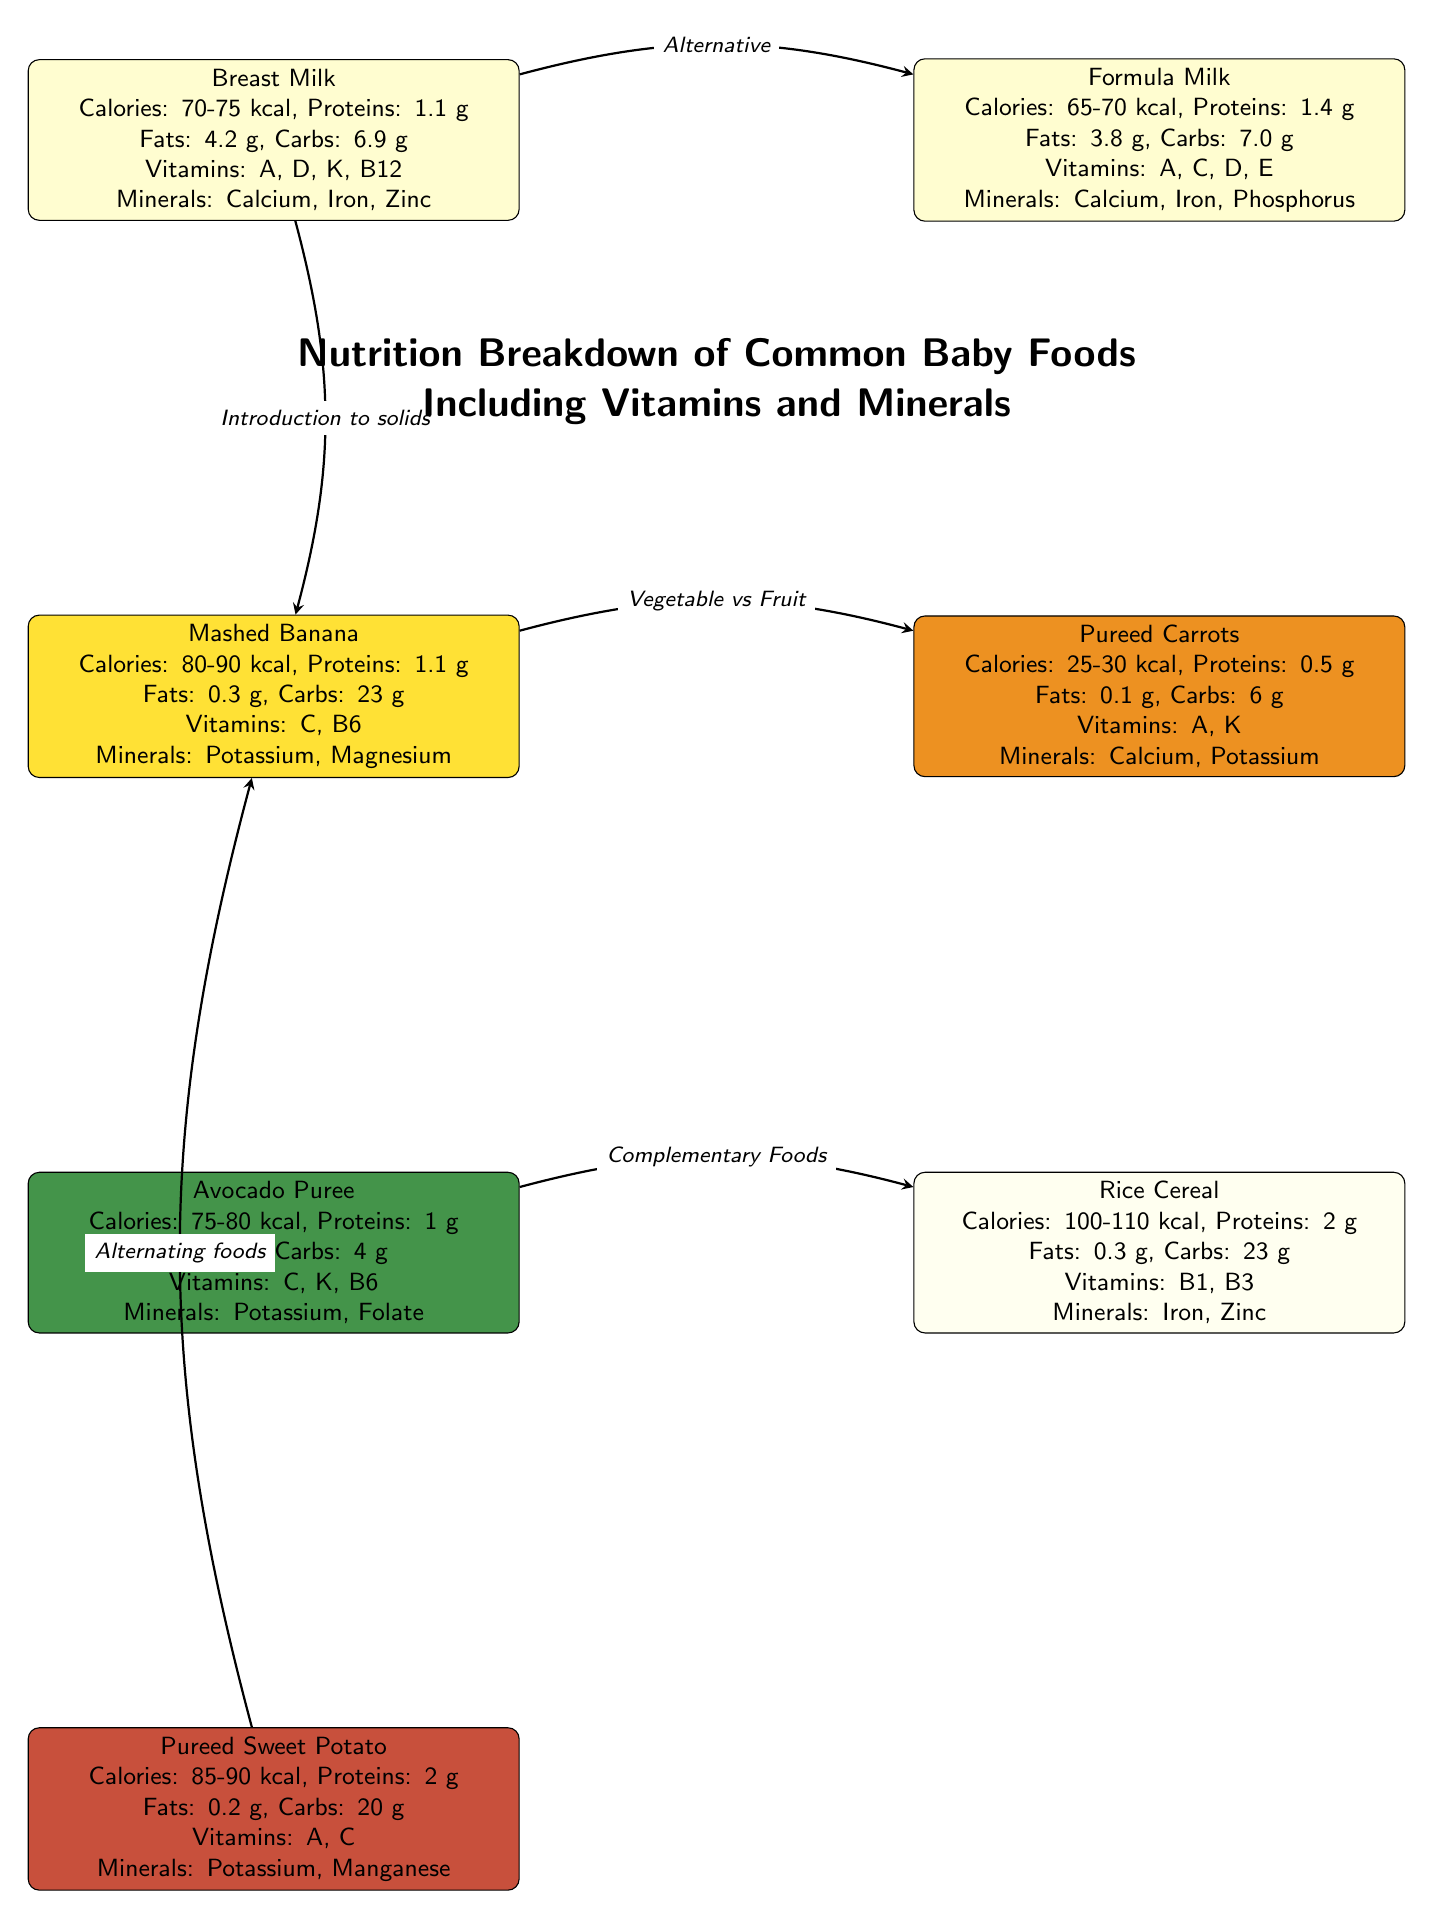What is the calorie range for Breast Milk? The diagram specifies that Breast Milk has a calorie range of 70-75 kcal. By referencing the node labeled "Breast Milk" and looking at the nutritional information listed, we find this value directly mentioned.
Answer: 70-75 kcal Which vitamin is present in both Avocado Puree and Mashed Banana? Both Avocado Puree and Mashed Banana include the vitamin C. By checking the vitamin lists under the respective nodes, we see that "C" appears in both cases.
Answer: C How many food items are listed in the diagram? The diagram includes six distinct food items: Breast Milk, Formula Milk, Mashed Banana, Pureed Carrots, Avocado Puree, Rice Cereal, and Pureed Sweet Potato. By simply counting the nodes in the diagram, we find the total.
Answer: 6 What is the main mineral found in both Pureed Sweet Potato and Mashed Banana? The main mineral found in both Pureed Sweet Potato and Mashed Banana is Potassium. Looking at the mineral sections in both food nodes, we identify Potassium listed under each.
Answer: Potassium What is the main dietary fat content of Pureed Carrots? The diagram states that Pureed Carrots contain 0.1 g of fat. This value can be located by reviewing the nutritional data associated specifically with the Pureed Carrots node.
Answer: 0.1 g Which two foods are identified as having Vitamins A and C? The two foods that have both Vitamins A and C are Pureed Sweet Potato and Avocado Puree. By examining the vitamins listed for each food, we can confirm that both indeed contain those vitamins.
Answer: Pureed Sweet Potato and Avocado Puree What are the calories in Rice Cereal? Rice Cereal contains 100-110 kcal, as detailed within its node under the nutrition breakdown. Reading that portion of the diagram, we find the specified calorie content.
Answer: 100-110 kcal Which food has more protein: Formula Milk or Rice Cereal? Formula Milk has 1.4 g of protein, whereas Rice Cereal has 2 g. By comparing the protein content listed in both nodes, we determine that Rice Cereal indeed has more protein.
Answer: Rice Cereal What does the arrow from Mashed Banana to Pureed Carrots represent? The arrow from Mashed Banana to Pureed Carrots indicates a comparison between a vegetable and a fruit. The label on the arrow states “Vegetable vs Fruit,” showing the relationship represented by the direction and labeling.
Answer: Vegetable vs Fruit Which food is connected to Breast Milk as an alternative feeding method? Formula Milk is connected to Breast Milk as an alternative feeding method. The arrow and the label identify this relationship clearly within the diagram.
Answer: Formula Milk 